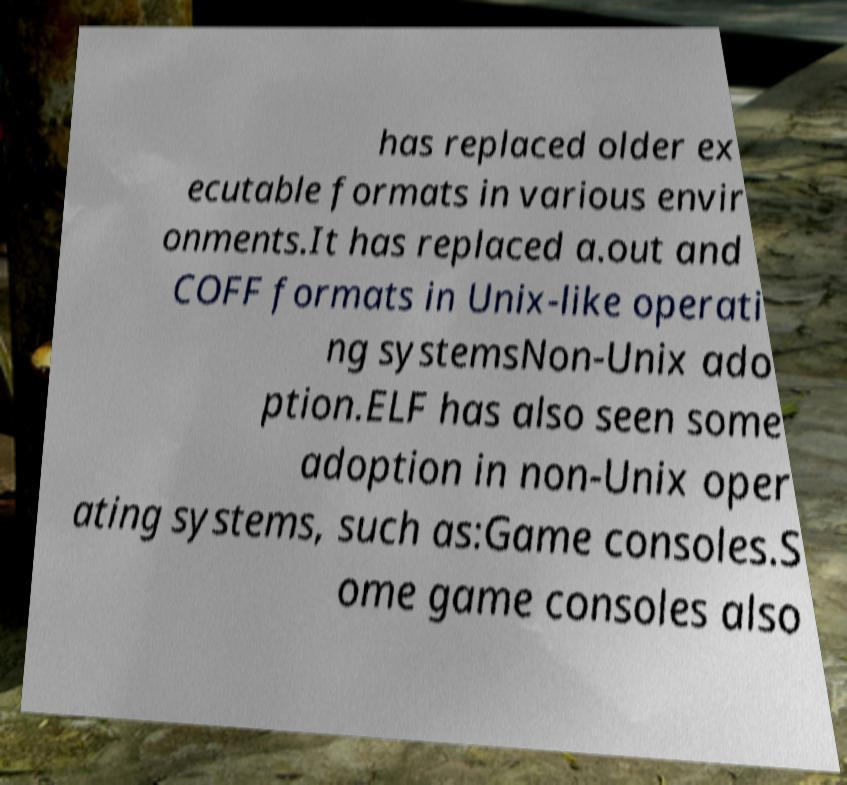There's text embedded in this image that I need extracted. Can you transcribe it verbatim? has replaced older ex ecutable formats in various envir onments.It has replaced a.out and COFF formats in Unix-like operati ng systemsNon-Unix ado ption.ELF has also seen some adoption in non-Unix oper ating systems, such as:Game consoles.S ome game consoles also 